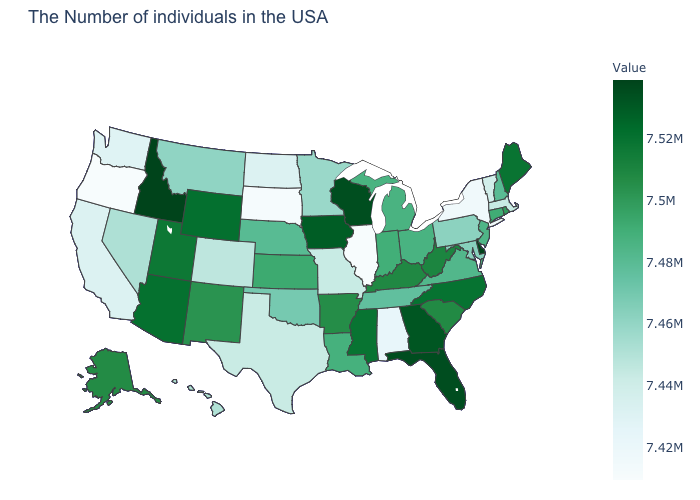Which states have the lowest value in the USA?
Be succinct. Illinois. Is the legend a continuous bar?
Write a very short answer. Yes. Is the legend a continuous bar?
Keep it brief. Yes. Which states hav the highest value in the MidWest?
Answer briefly. Wisconsin. Among the states that border Minnesota , does South Dakota have the highest value?
Give a very brief answer. No. Among the states that border Arkansas , does Texas have the highest value?
Short answer required. No. 